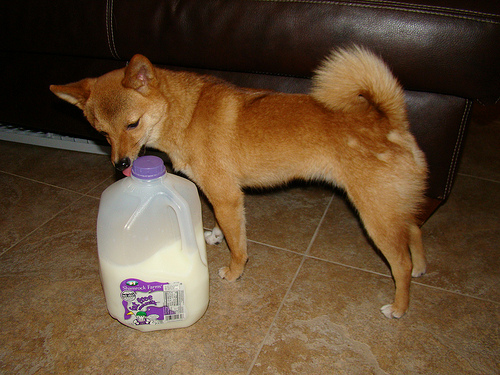<image>
Can you confirm if the milk is under the dog? No. The milk is not positioned under the dog. The vertical relationship between these objects is different. Is there a dog in front of the milk? No. The dog is not in front of the milk. The spatial positioning shows a different relationship between these objects. 